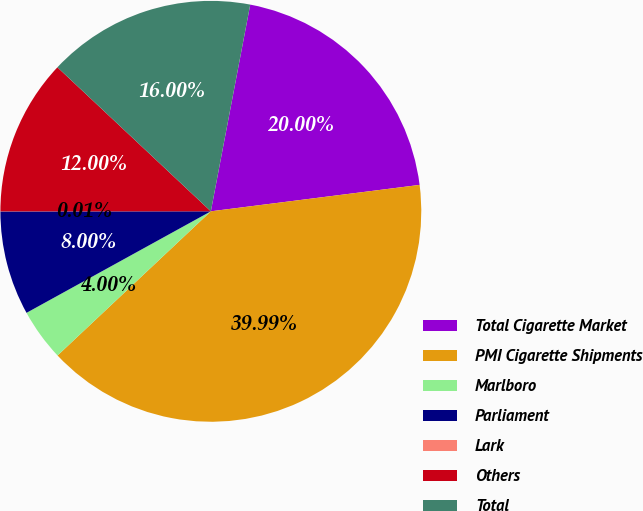Convert chart. <chart><loc_0><loc_0><loc_500><loc_500><pie_chart><fcel>Total Cigarette Market<fcel>PMI Cigarette Shipments<fcel>Marlboro<fcel>Parliament<fcel>Lark<fcel>Others<fcel>Total<nl><fcel>20.0%<fcel>39.99%<fcel>4.0%<fcel>8.0%<fcel>0.01%<fcel>12.0%<fcel>16.0%<nl></chart> 